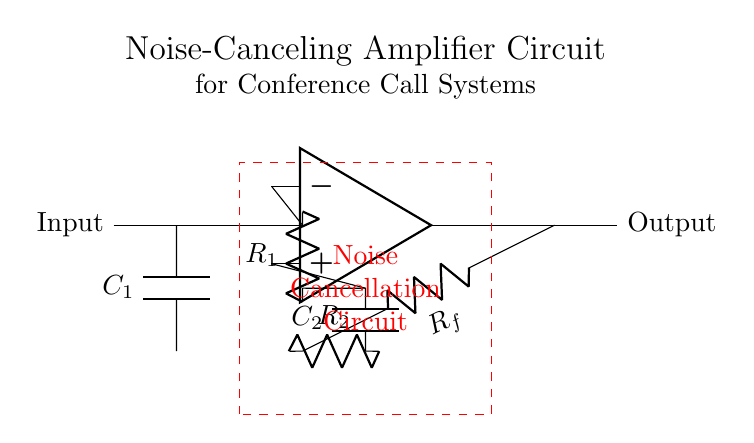What types of components are used in this circuit? The circuit uses capacitors, resistors, and an operational amplifier (op amp). The capacitors are labeled as C1 and C2, the resistors as R1, R2, and Rf, while the operational amplifier is represented by the op amp symbol.
Answer: capacitors, resistors, op amp What is the function of the feedback resistor Rf? The feedback resistor Rf is part of the feedback loop that helps stabilize the output voltage of the operational amplifier by providing a path for a portion of the output back to the inverting input. This ensures the amplifier operates in a controlled manner and helps define the gain of the amplifier.
Answer: stabilizes output What is the purpose of the noise cancellation circuit? The noise cancellation circuit, indicated by the dashed rectangle, aims to reduce or eliminate unwanted noise from the audio input before it is amplified. This is crucial in conference call systems to enhance audio clarity by ensuring that background noise does not interfere with the primary audio signal.
Answer: reduce noise How many capacitors are in the circuit? There are two capacitors, C1 and C2, in the circuit as indicated by their labels and positions. They are used for coupling and frequency response shaping within the amplifier.
Answer: two What role does the capacitor C2 play in the circuit? Capacitor C2 is in parallel with resistor R2 in the feedback loop, which allows for frequency-dependent feedback in the circuit. It contributes to the overall frequency response and helps tailor the amplifier's behavior to effectively cancel noise.
Answer: feedback role What is the expected output behavior regarding audio quality? The expected output behavior is that the circuit will improve audio quality by amplifying the desired audio signal while effectively canceling out background noise, resulting in clearer sound during conference calls.
Answer: improve audio quality 